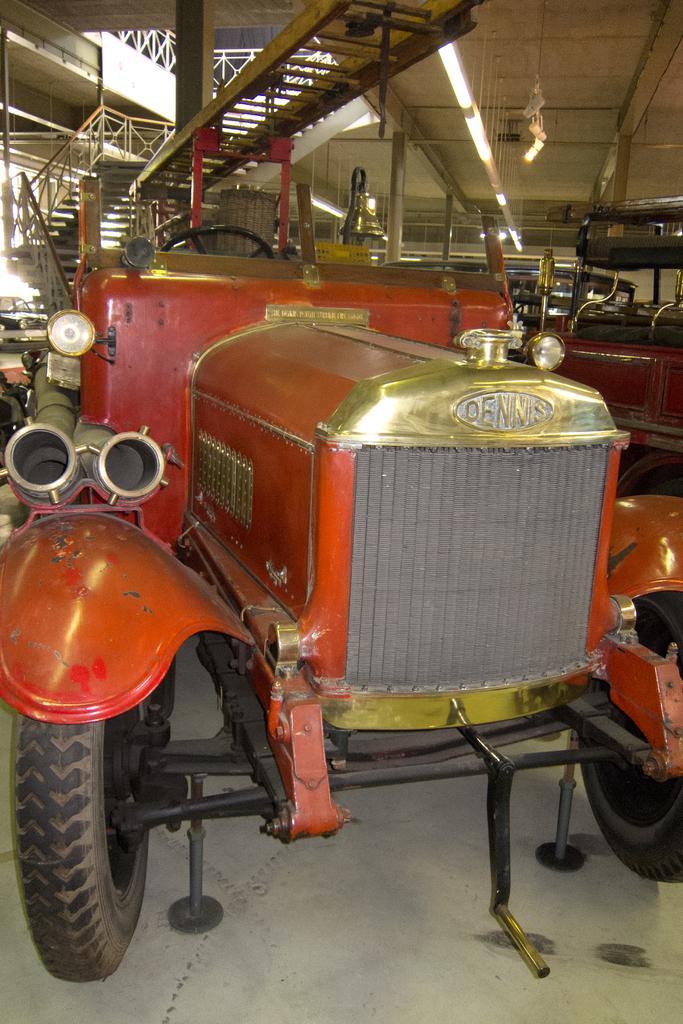Can you describe this image briefly? In this picture in the front there is a Vintage car. In the background there is a staircase, there are pillars and there are vehicles. On the left side there is a wall and there is a balcony which is white in colour. 